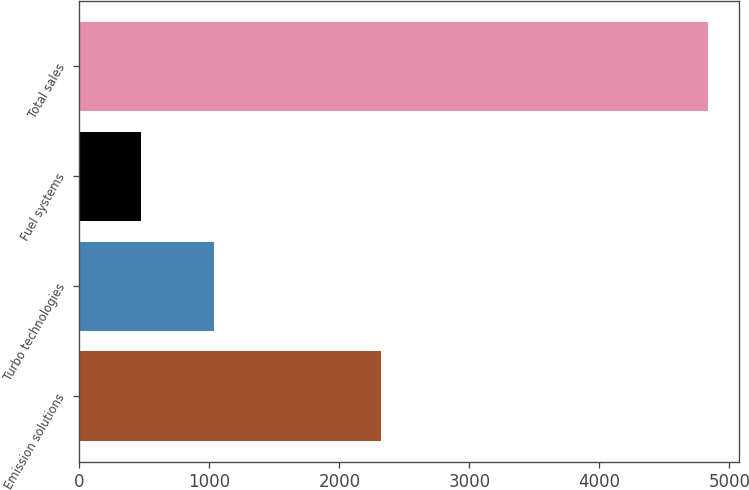<chart> <loc_0><loc_0><loc_500><loc_500><bar_chart><fcel>Emission solutions<fcel>Turbo technologies<fcel>Fuel systems<fcel>Total sales<nl><fcel>2317<fcel>1036<fcel>473<fcel>4836<nl></chart> 